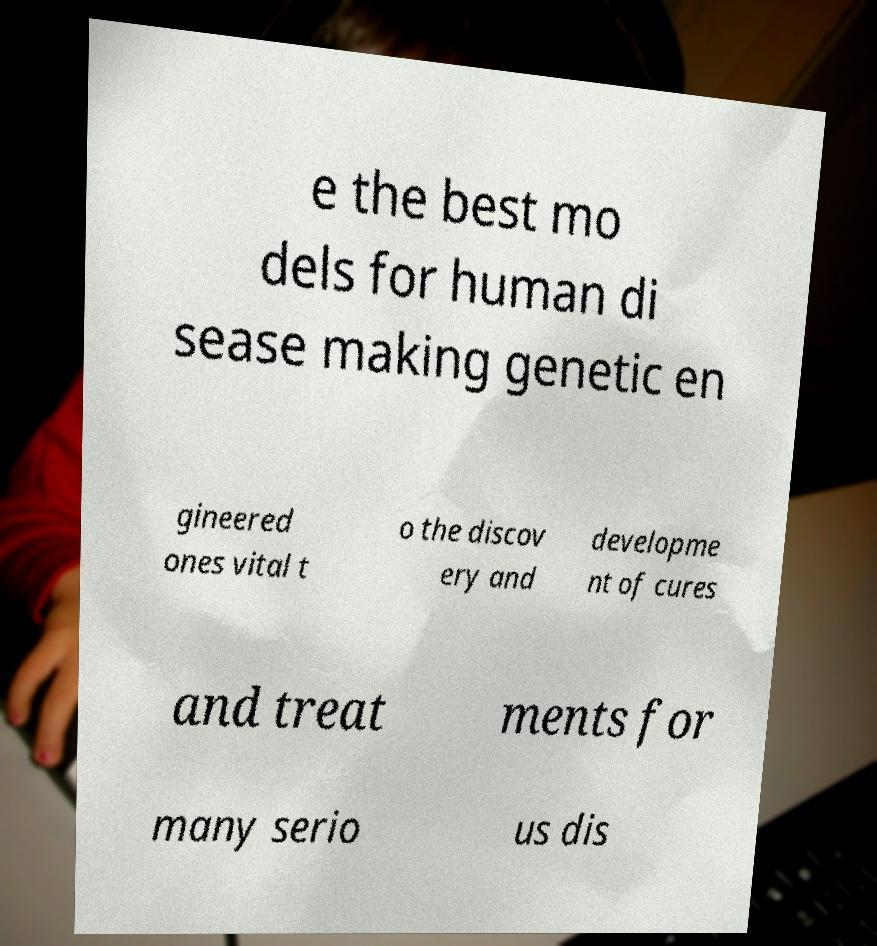Please identify and transcribe the text found in this image. e the best mo dels for human di sease making genetic en gineered ones vital t o the discov ery and developme nt of cures and treat ments for many serio us dis 